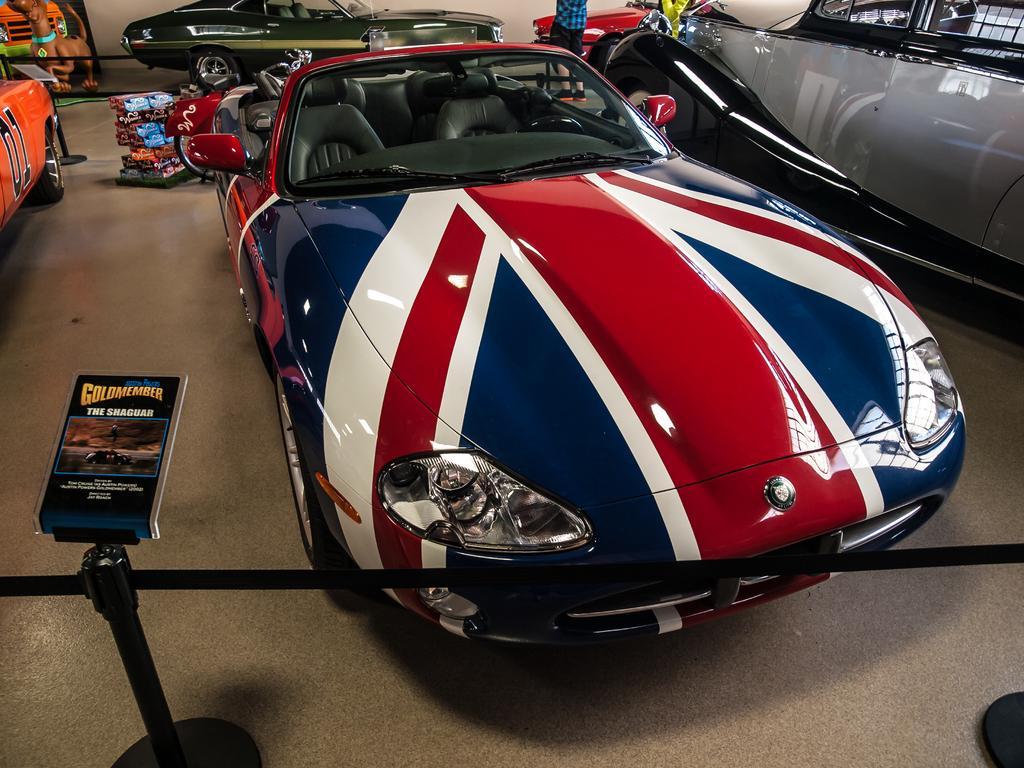Can you describe this image briefly? In this image there are vehicles, people, boards, stands and objects. On the board there is an image of a dog. 